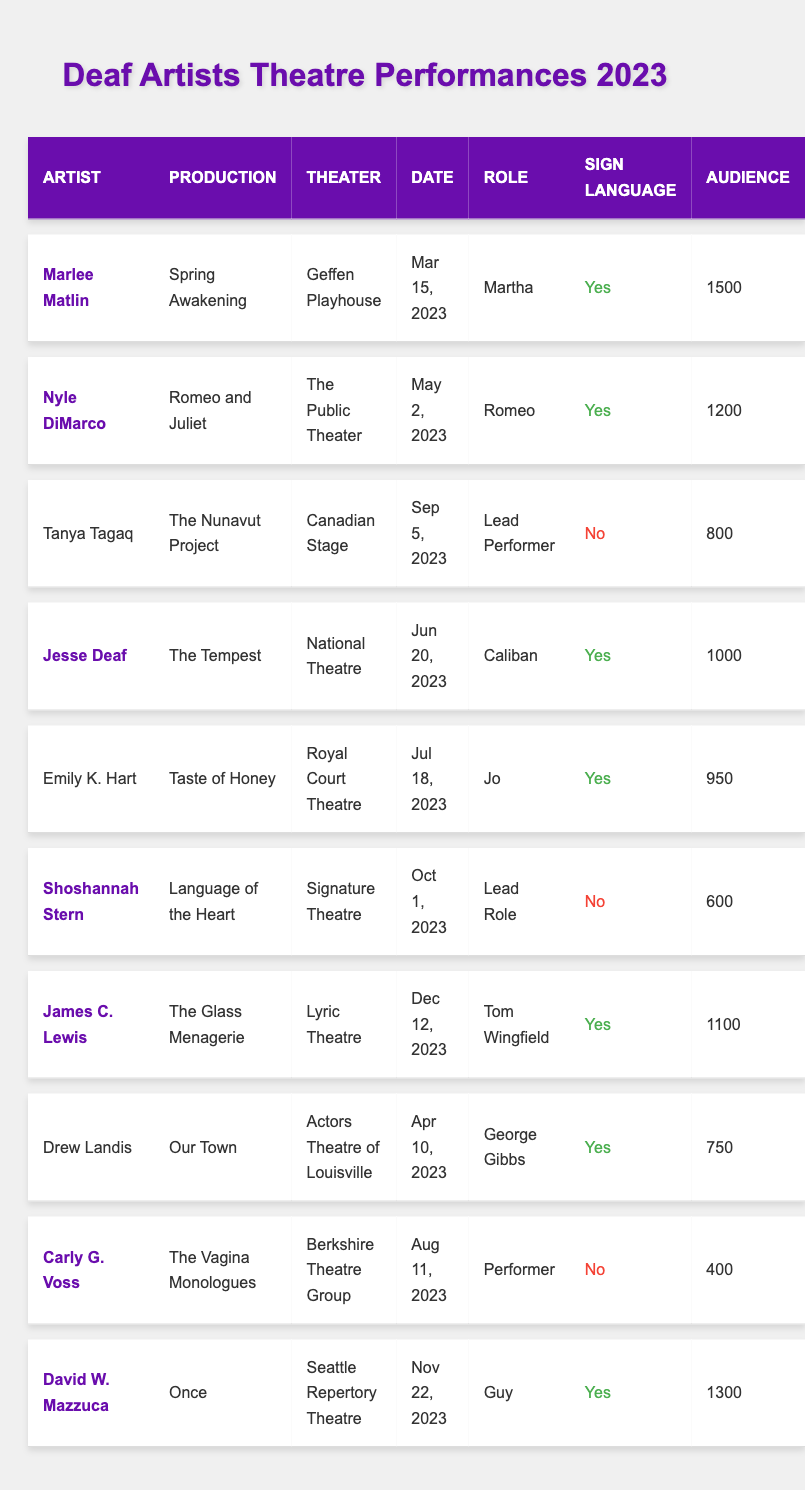What is the name of the artist performing in "Romeo and Juliet"? The table shows that Nyle DiMarco is the artist performing in "Romeo and Juliet".
Answer: Nyle DiMarco How many audience members attended "Spring Awakening"? The table indicates that "Spring Awakening" had an audience size of 1500.
Answer: 1500 Which production had the lowest audience size? By reviewing the audience sizes, "The Vagina Monologues" had the lowest audience size at 400.
Answer: 400 Did Emily K. Hart use sign language in "Taste of Honey"? The table indicates that Emily K. Hart did use sign language in the production of "Taste of Honey".
Answer: Yes How many performances used sign language in total? There are 6 performances that used sign language, which can be counted from the "Sign Language" column where "Yes" appears.
Answer: 6 Which artist had the highest audience size? Comparing all the audience sizes, Marlee Matlin had the highest with 1500 attendees.
Answer: Marlee Matlin What role did Jesse Deaf play in "The Tempest"? According to the table, Jesse Deaf played the role of Caliban in "The Tempest".
Answer: Caliban How many productions were acclaimed? The table shows that 6 out of 10 productions were marked as acclaimed, based on the "is_acclaimed" column.
Answer: 6 List all performances that did not use sign language. The performances without sign language are from Tanya Tagaq, Shoshannah Stern, and Carly G. Voss, as indicated in the "Sign Language" column.
Answer: 3 artists Which theater had a performance with the second-largest audience size? The theater "David W. Mazzuca" at Seattle Repertory Theatre had the second-largest audience size of 1300, following "Spring Awakening".
Answer: Seattle Repertory Theatre What is the average audience size for productions that used sign language? The audience sizes for sign language productions are 1500, 1200, 1000, 950, 1100, and 1300, giving a total of 8200, and the average size is 8200 / 6 = 1366.67.
Answer: 1366.67 Which deaf artist performed in the latest production? James C. Lewis is scheduled for the latest production of "The Glass Menagerie" on December 12, 2023, according to the date listed in the table.
Answer: James C. Lewis 